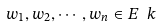Convert formula to latex. <formula><loc_0><loc_0><loc_500><loc_500>w _ { 1 } , w _ { 2 } , \cdots , w _ { n } \in E \ k</formula> 